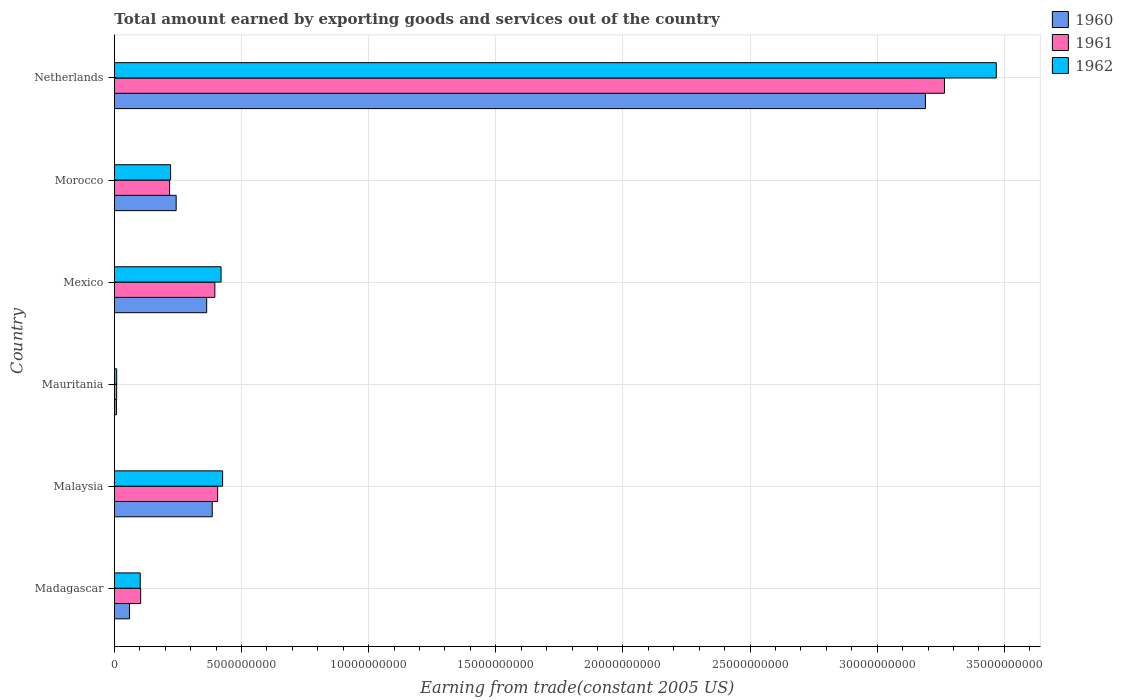How many bars are there on the 1st tick from the top?
Offer a very short reply. 3. What is the label of the 5th group of bars from the top?
Make the answer very short. Malaysia. In how many cases, is the number of bars for a given country not equal to the number of legend labels?
Offer a very short reply. 0. What is the total amount earned by exporting goods and services in 1961 in Malaysia?
Offer a terse response. 4.06e+09. Across all countries, what is the maximum total amount earned by exporting goods and services in 1962?
Keep it short and to the point. 3.47e+1. Across all countries, what is the minimum total amount earned by exporting goods and services in 1961?
Give a very brief answer. 8.64e+07. In which country was the total amount earned by exporting goods and services in 1961 maximum?
Your answer should be very brief. Netherlands. In which country was the total amount earned by exporting goods and services in 1962 minimum?
Offer a terse response. Mauritania. What is the total total amount earned by exporting goods and services in 1962 in the graph?
Offer a terse response. 4.64e+1. What is the difference between the total amount earned by exporting goods and services in 1961 in Malaysia and that in Mexico?
Give a very brief answer. 1.10e+08. What is the difference between the total amount earned by exporting goods and services in 1960 in Netherlands and the total amount earned by exporting goods and services in 1962 in Madagascar?
Provide a short and direct response. 3.09e+1. What is the average total amount earned by exporting goods and services in 1962 per country?
Make the answer very short. 7.74e+09. What is the difference between the total amount earned by exporting goods and services in 1960 and total amount earned by exporting goods and services in 1961 in Morocco?
Offer a very short reply. 2.59e+08. What is the ratio of the total amount earned by exporting goods and services in 1961 in Mauritania to that in Morocco?
Your answer should be compact. 0.04. Is the total amount earned by exporting goods and services in 1960 in Madagascar less than that in Mexico?
Offer a terse response. Yes. What is the difference between the highest and the second highest total amount earned by exporting goods and services in 1962?
Make the answer very short. 3.04e+1. What is the difference between the highest and the lowest total amount earned by exporting goods and services in 1962?
Your answer should be very brief. 3.46e+1. In how many countries, is the total amount earned by exporting goods and services in 1960 greater than the average total amount earned by exporting goods and services in 1960 taken over all countries?
Offer a very short reply. 1. What does the 1st bar from the top in Mexico represents?
Give a very brief answer. 1962. How many bars are there?
Provide a short and direct response. 18. What is the difference between two consecutive major ticks on the X-axis?
Offer a terse response. 5.00e+09. Where does the legend appear in the graph?
Offer a very short reply. Top right. How are the legend labels stacked?
Make the answer very short. Vertical. What is the title of the graph?
Your answer should be compact. Total amount earned by exporting goods and services out of the country. Does "1961" appear as one of the legend labels in the graph?
Give a very brief answer. Yes. What is the label or title of the X-axis?
Ensure brevity in your answer.  Earning from trade(constant 2005 US). What is the Earning from trade(constant 2005 US) in 1960 in Madagascar?
Provide a short and direct response. 5.92e+08. What is the Earning from trade(constant 2005 US) in 1961 in Madagascar?
Keep it short and to the point. 1.03e+09. What is the Earning from trade(constant 2005 US) in 1962 in Madagascar?
Provide a succinct answer. 1.02e+09. What is the Earning from trade(constant 2005 US) of 1960 in Malaysia?
Ensure brevity in your answer.  3.85e+09. What is the Earning from trade(constant 2005 US) of 1961 in Malaysia?
Offer a terse response. 4.06e+09. What is the Earning from trade(constant 2005 US) in 1962 in Malaysia?
Offer a terse response. 4.25e+09. What is the Earning from trade(constant 2005 US) of 1960 in Mauritania?
Provide a succinct answer. 7.97e+07. What is the Earning from trade(constant 2005 US) in 1961 in Mauritania?
Your answer should be compact. 8.64e+07. What is the Earning from trade(constant 2005 US) of 1962 in Mauritania?
Your answer should be compact. 8.95e+07. What is the Earning from trade(constant 2005 US) in 1960 in Mexico?
Make the answer very short. 3.63e+09. What is the Earning from trade(constant 2005 US) of 1961 in Mexico?
Give a very brief answer. 3.95e+09. What is the Earning from trade(constant 2005 US) in 1962 in Mexico?
Make the answer very short. 4.19e+09. What is the Earning from trade(constant 2005 US) in 1960 in Morocco?
Your answer should be compact. 2.43e+09. What is the Earning from trade(constant 2005 US) of 1961 in Morocco?
Ensure brevity in your answer.  2.17e+09. What is the Earning from trade(constant 2005 US) of 1962 in Morocco?
Offer a very short reply. 2.21e+09. What is the Earning from trade(constant 2005 US) in 1960 in Netherlands?
Offer a very short reply. 3.19e+1. What is the Earning from trade(constant 2005 US) in 1961 in Netherlands?
Keep it short and to the point. 3.26e+1. What is the Earning from trade(constant 2005 US) of 1962 in Netherlands?
Make the answer very short. 3.47e+1. Across all countries, what is the maximum Earning from trade(constant 2005 US) in 1960?
Ensure brevity in your answer.  3.19e+1. Across all countries, what is the maximum Earning from trade(constant 2005 US) in 1961?
Give a very brief answer. 3.26e+1. Across all countries, what is the maximum Earning from trade(constant 2005 US) in 1962?
Ensure brevity in your answer.  3.47e+1. Across all countries, what is the minimum Earning from trade(constant 2005 US) of 1960?
Your answer should be compact. 7.97e+07. Across all countries, what is the minimum Earning from trade(constant 2005 US) of 1961?
Your response must be concise. 8.64e+07. Across all countries, what is the minimum Earning from trade(constant 2005 US) of 1962?
Offer a very short reply. 8.95e+07. What is the total Earning from trade(constant 2005 US) in 1960 in the graph?
Your answer should be very brief. 4.25e+1. What is the total Earning from trade(constant 2005 US) in 1961 in the graph?
Your answer should be compact. 4.39e+1. What is the total Earning from trade(constant 2005 US) of 1962 in the graph?
Your answer should be very brief. 4.64e+1. What is the difference between the Earning from trade(constant 2005 US) of 1960 in Madagascar and that in Malaysia?
Offer a terse response. -3.26e+09. What is the difference between the Earning from trade(constant 2005 US) of 1961 in Madagascar and that in Malaysia?
Your response must be concise. -3.03e+09. What is the difference between the Earning from trade(constant 2005 US) in 1962 in Madagascar and that in Malaysia?
Provide a succinct answer. -3.24e+09. What is the difference between the Earning from trade(constant 2005 US) of 1960 in Madagascar and that in Mauritania?
Offer a terse response. 5.12e+08. What is the difference between the Earning from trade(constant 2005 US) of 1961 in Madagascar and that in Mauritania?
Provide a short and direct response. 9.45e+08. What is the difference between the Earning from trade(constant 2005 US) of 1962 in Madagascar and that in Mauritania?
Offer a terse response. 9.26e+08. What is the difference between the Earning from trade(constant 2005 US) of 1960 in Madagascar and that in Mexico?
Your answer should be very brief. -3.04e+09. What is the difference between the Earning from trade(constant 2005 US) in 1961 in Madagascar and that in Mexico?
Offer a very short reply. -2.92e+09. What is the difference between the Earning from trade(constant 2005 US) of 1962 in Madagascar and that in Mexico?
Provide a succinct answer. -3.18e+09. What is the difference between the Earning from trade(constant 2005 US) of 1960 in Madagascar and that in Morocco?
Offer a terse response. -1.84e+09. What is the difference between the Earning from trade(constant 2005 US) in 1961 in Madagascar and that in Morocco?
Keep it short and to the point. -1.14e+09. What is the difference between the Earning from trade(constant 2005 US) of 1962 in Madagascar and that in Morocco?
Provide a short and direct response. -1.19e+09. What is the difference between the Earning from trade(constant 2005 US) of 1960 in Madagascar and that in Netherlands?
Give a very brief answer. -3.13e+1. What is the difference between the Earning from trade(constant 2005 US) in 1961 in Madagascar and that in Netherlands?
Offer a terse response. -3.16e+1. What is the difference between the Earning from trade(constant 2005 US) in 1962 in Madagascar and that in Netherlands?
Your answer should be very brief. -3.37e+1. What is the difference between the Earning from trade(constant 2005 US) in 1960 in Malaysia and that in Mauritania?
Give a very brief answer. 3.77e+09. What is the difference between the Earning from trade(constant 2005 US) of 1961 in Malaysia and that in Mauritania?
Offer a terse response. 3.97e+09. What is the difference between the Earning from trade(constant 2005 US) of 1962 in Malaysia and that in Mauritania?
Your answer should be very brief. 4.17e+09. What is the difference between the Earning from trade(constant 2005 US) in 1960 in Malaysia and that in Mexico?
Make the answer very short. 2.18e+08. What is the difference between the Earning from trade(constant 2005 US) in 1961 in Malaysia and that in Mexico?
Your response must be concise. 1.10e+08. What is the difference between the Earning from trade(constant 2005 US) in 1962 in Malaysia and that in Mexico?
Ensure brevity in your answer.  6.04e+07. What is the difference between the Earning from trade(constant 2005 US) of 1960 in Malaysia and that in Morocco?
Your response must be concise. 1.42e+09. What is the difference between the Earning from trade(constant 2005 US) in 1961 in Malaysia and that in Morocco?
Give a very brief answer. 1.89e+09. What is the difference between the Earning from trade(constant 2005 US) in 1962 in Malaysia and that in Morocco?
Your answer should be compact. 2.05e+09. What is the difference between the Earning from trade(constant 2005 US) in 1960 in Malaysia and that in Netherlands?
Your response must be concise. -2.81e+1. What is the difference between the Earning from trade(constant 2005 US) in 1961 in Malaysia and that in Netherlands?
Your response must be concise. -2.86e+1. What is the difference between the Earning from trade(constant 2005 US) in 1962 in Malaysia and that in Netherlands?
Your response must be concise. -3.04e+1. What is the difference between the Earning from trade(constant 2005 US) in 1960 in Mauritania and that in Mexico?
Provide a short and direct response. -3.55e+09. What is the difference between the Earning from trade(constant 2005 US) of 1961 in Mauritania and that in Mexico?
Give a very brief answer. -3.86e+09. What is the difference between the Earning from trade(constant 2005 US) in 1962 in Mauritania and that in Mexico?
Your answer should be compact. -4.10e+09. What is the difference between the Earning from trade(constant 2005 US) of 1960 in Mauritania and that in Morocco?
Offer a very short reply. -2.35e+09. What is the difference between the Earning from trade(constant 2005 US) of 1961 in Mauritania and that in Morocco?
Make the answer very short. -2.08e+09. What is the difference between the Earning from trade(constant 2005 US) of 1962 in Mauritania and that in Morocco?
Your answer should be compact. -2.12e+09. What is the difference between the Earning from trade(constant 2005 US) of 1960 in Mauritania and that in Netherlands?
Your response must be concise. -3.18e+1. What is the difference between the Earning from trade(constant 2005 US) of 1961 in Mauritania and that in Netherlands?
Make the answer very short. -3.26e+1. What is the difference between the Earning from trade(constant 2005 US) in 1962 in Mauritania and that in Netherlands?
Offer a terse response. -3.46e+1. What is the difference between the Earning from trade(constant 2005 US) of 1960 in Mexico and that in Morocco?
Your answer should be very brief. 1.20e+09. What is the difference between the Earning from trade(constant 2005 US) in 1961 in Mexico and that in Morocco?
Offer a terse response. 1.78e+09. What is the difference between the Earning from trade(constant 2005 US) in 1962 in Mexico and that in Morocco?
Your response must be concise. 1.99e+09. What is the difference between the Earning from trade(constant 2005 US) in 1960 in Mexico and that in Netherlands?
Keep it short and to the point. -2.83e+1. What is the difference between the Earning from trade(constant 2005 US) in 1961 in Mexico and that in Netherlands?
Keep it short and to the point. -2.87e+1. What is the difference between the Earning from trade(constant 2005 US) in 1962 in Mexico and that in Netherlands?
Offer a terse response. -3.05e+1. What is the difference between the Earning from trade(constant 2005 US) of 1960 in Morocco and that in Netherlands?
Provide a succinct answer. -2.95e+1. What is the difference between the Earning from trade(constant 2005 US) in 1961 in Morocco and that in Netherlands?
Your answer should be compact. -3.05e+1. What is the difference between the Earning from trade(constant 2005 US) in 1962 in Morocco and that in Netherlands?
Your answer should be compact. -3.25e+1. What is the difference between the Earning from trade(constant 2005 US) in 1960 in Madagascar and the Earning from trade(constant 2005 US) in 1961 in Malaysia?
Offer a terse response. -3.47e+09. What is the difference between the Earning from trade(constant 2005 US) in 1960 in Madagascar and the Earning from trade(constant 2005 US) in 1962 in Malaysia?
Keep it short and to the point. -3.66e+09. What is the difference between the Earning from trade(constant 2005 US) in 1961 in Madagascar and the Earning from trade(constant 2005 US) in 1962 in Malaysia?
Ensure brevity in your answer.  -3.22e+09. What is the difference between the Earning from trade(constant 2005 US) in 1960 in Madagascar and the Earning from trade(constant 2005 US) in 1961 in Mauritania?
Offer a terse response. 5.05e+08. What is the difference between the Earning from trade(constant 2005 US) of 1960 in Madagascar and the Earning from trade(constant 2005 US) of 1962 in Mauritania?
Give a very brief answer. 5.02e+08. What is the difference between the Earning from trade(constant 2005 US) in 1961 in Madagascar and the Earning from trade(constant 2005 US) in 1962 in Mauritania?
Your answer should be very brief. 9.42e+08. What is the difference between the Earning from trade(constant 2005 US) of 1960 in Madagascar and the Earning from trade(constant 2005 US) of 1961 in Mexico?
Provide a succinct answer. -3.36e+09. What is the difference between the Earning from trade(constant 2005 US) of 1960 in Madagascar and the Earning from trade(constant 2005 US) of 1962 in Mexico?
Provide a succinct answer. -3.60e+09. What is the difference between the Earning from trade(constant 2005 US) in 1961 in Madagascar and the Earning from trade(constant 2005 US) in 1962 in Mexico?
Your response must be concise. -3.16e+09. What is the difference between the Earning from trade(constant 2005 US) of 1960 in Madagascar and the Earning from trade(constant 2005 US) of 1961 in Morocco?
Ensure brevity in your answer.  -1.58e+09. What is the difference between the Earning from trade(constant 2005 US) in 1960 in Madagascar and the Earning from trade(constant 2005 US) in 1962 in Morocco?
Make the answer very short. -1.62e+09. What is the difference between the Earning from trade(constant 2005 US) in 1961 in Madagascar and the Earning from trade(constant 2005 US) in 1962 in Morocco?
Provide a short and direct response. -1.18e+09. What is the difference between the Earning from trade(constant 2005 US) of 1960 in Madagascar and the Earning from trade(constant 2005 US) of 1961 in Netherlands?
Your answer should be very brief. -3.21e+1. What is the difference between the Earning from trade(constant 2005 US) in 1960 in Madagascar and the Earning from trade(constant 2005 US) in 1962 in Netherlands?
Provide a short and direct response. -3.41e+1. What is the difference between the Earning from trade(constant 2005 US) in 1961 in Madagascar and the Earning from trade(constant 2005 US) in 1962 in Netherlands?
Provide a short and direct response. -3.37e+1. What is the difference between the Earning from trade(constant 2005 US) in 1960 in Malaysia and the Earning from trade(constant 2005 US) in 1961 in Mauritania?
Offer a terse response. 3.76e+09. What is the difference between the Earning from trade(constant 2005 US) of 1960 in Malaysia and the Earning from trade(constant 2005 US) of 1962 in Mauritania?
Your answer should be very brief. 3.76e+09. What is the difference between the Earning from trade(constant 2005 US) in 1961 in Malaysia and the Earning from trade(constant 2005 US) in 1962 in Mauritania?
Keep it short and to the point. 3.97e+09. What is the difference between the Earning from trade(constant 2005 US) of 1960 in Malaysia and the Earning from trade(constant 2005 US) of 1961 in Mexico?
Offer a very short reply. -1.02e+08. What is the difference between the Earning from trade(constant 2005 US) in 1960 in Malaysia and the Earning from trade(constant 2005 US) in 1962 in Mexico?
Your answer should be compact. -3.48e+08. What is the difference between the Earning from trade(constant 2005 US) in 1961 in Malaysia and the Earning from trade(constant 2005 US) in 1962 in Mexico?
Provide a succinct answer. -1.35e+08. What is the difference between the Earning from trade(constant 2005 US) of 1960 in Malaysia and the Earning from trade(constant 2005 US) of 1961 in Morocco?
Your answer should be very brief. 1.68e+09. What is the difference between the Earning from trade(constant 2005 US) in 1960 in Malaysia and the Earning from trade(constant 2005 US) in 1962 in Morocco?
Offer a terse response. 1.64e+09. What is the difference between the Earning from trade(constant 2005 US) in 1961 in Malaysia and the Earning from trade(constant 2005 US) in 1962 in Morocco?
Provide a succinct answer. 1.85e+09. What is the difference between the Earning from trade(constant 2005 US) in 1960 in Malaysia and the Earning from trade(constant 2005 US) in 1961 in Netherlands?
Provide a short and direct response. -2.88e+1. What is the difference between the Earning from trade(constant 2005 US) of 1960 in Malaysia and the Earning from trade(constant 2005 US) of 1962 in Netherlands?
Ensure brevity in your answer.  -3.08e+1. What is the difference between the Earning from trade(constant 2005 US) of 1961 in Malaysia and the Earning from trade(constant 2005 US) of 1962 in Netherlands?
Ensure brevity in your answer.  -3.06e+1. What is the difference between the Earning from trade(constant 2005 US) of 1960 in Mauritania and the Earning from trade(constant 2005 US) of 1961 in Mexico?
Your answer should be compact. -3.87e+09. What is the difference between the Earning from trade(constant 2005 US) in 1960 in Mauritania and the Earning from trade(constant 2005 US) in 1962 in Mexico?
Make the answer very short. -4.11e+09. What is the difference between the Earning from trade(constant 2005 US) in 1961 in Mauritania and the Earning from trade(constant 2005 US) in 1962 in Mexico?
Ensure brevity in your answer.  -4.11e+09. What is the difference between the Earning from trade(constant 2005 US) in 1960 in Mauritania and the Earning from trade(constant 2005 US) in 1961 in Morocco?
Your answer should be compact. -2.09e+09. What is the difference between the Earning from trade(constant 2005 US) of 1960 in Mauritania and the Earning from trade(constant 2005 US) of 1962 in Morocco?
Your answer should be compact. -2.13e+09. What is the difference between the Earning from trade(constant 2005 US) of 1961 in Mauritania and the Earning from trade(constant 2005 US) of 1962 in Morocco?
Provide a succinct answer. -2.12e+09. What is the difference between the Earning from trade(constant 2005 US) in 1960 in Mauritania and the Earning from trade(constant 2005 US) in 1961 in Netherlands?
Your response must be concise. -3.26e+1. What is the difference between the Earning from trade(constant 2005 US) in 1960 in Mauritania and the Earning from trade(constant 2005 US) in 1962 in Netherlands?
Keep it short and to the point. -3.46e+1. What is the difference between the Earning from trade(constant 2005 US) in 1961 in Mauritania and the Earning from trade(constant 2005 US) in 1962 in Netherlands?
Keep it short and to the point. -3.46e+1. What is the difference between the Earning from trade(constant 2005 US) of 1960 in Mexico and the Earning from trade(constant 2005 US) of 1961 in Morocco?
Your answer should be very brief. 1.46e+09. What is the difference between the Earning from trade(constant 2005 US) in 1960 in Mexico and the Earning from trade(constant 2005 US) in 1962 in Morocco?
Your answer should be very brief. 1.42e+09. What is the difference between the Earning from trade(constant 2005 US) in 1961 in Mexico and the Earning from trade(constant 2005 US) in 1962 in Morocco?
Make the answer very short. 1.74e+09. What is the difference between the Earning from trade(constant 2005 US) in 1960 in Mexico and the Earning from trade(constant 2005 US) in 1961 in Netherlands?
Your response must be concise. -2.90e+1. What is the difference between the Earning from trade(constant 2005 US) in 1960 in Mexico and the Earning from trade(constant 2005 US) in 1962 in Netherlands?
Ensure brevity in your answer.  -3.11e+1. What is the difference between the Earning from trade(constant 2005 US) of 1961 in Mexico and the Earning from trade(constant 2005 US) of 1962 in Netherlands?
Provide a succinct answer. -3.07e+1. What is the difference between the Earning from trade(constant 2005 US) in 1960 in Morocco and the Earning from trade(constant 2005 US) in 1961 in Netherlands?
Offer a terse response. -3.02e+1. What is the difference between the Earning from trade(constant 2005 US) in 1960 in Morocco and the Earning from trade(constant 2005 US) in 1962 in Netherlands?
Keep it short and to the point. -3.23e+1. What is the difference between the Earning from trade(constant 2005 US) of 1961 in Morocco and the Earning from trade(constant 2005 US) of 1962 in Netherlands?
Your answer should be compact. -3.25e+1. What is the average Earning from trade(constant 2005 US) in 1960 per country?
Your answer should be very brief. 7.08e+09. What is the average Earning from trade(constant 2005 US) of 1961 per country?
Make the answer very short. 7.32e+09. What is the average Earning from trade(constant 2005 US) of 1962 per country?
Provide a succinct answer. 7.74e+09. What is the difference between the Earning from trade(constant 2005 US) of 1960 and Earning from trade(constant 2005 US) of 1961 in Madagascar?
Keep it short and to the point. -4.40e+08. What is the difference between the Earning from trade(constant 2005 US) of 1960 and Earning from trade(constant 2005 US) of 1962 in Madagascar?
Make the answer very short. -4.24e+08. What is the difference between the Earning from trade(constant 2005 US) in 1961 and Earning from trade(constant 2005 US) in 1962 in Madagascar?
Ensure brevity in your answer.  1.61e+07. What is the difference between the Earning from trade(constant 2005 US) in 1960 and Earning from trade(constant 2005 US) in 1961 in Malaysia?
Your response must be concise. -2.13e+08. What is the difference between the Earning from trade(constant 2005 US) of 1960 and Earning from trade(constant 2005 US) of 1962 in Malaysia?
Ensure brevity in your answer.  -4.08e+08. What is the difference between the Earning from trade(constant 2005 US) in 1961 and Earning from trade(constant 2005 US) in 1962 in Malaysia?
Ensure brevity in your answer.  -1.95e+08. What is the difference between the Earning from trade(constant 2005 US) of 1960 and Earning from trade(constant 2005 US) of 1961 in Mauritania?
Offer a terse response. -6.74e+06. What is the difference between the Earning from trade(constant 2005 US) of 1960 and Earning from trade(constant 2005 US) of 1962 in Mauritania?
Provide a short and direct response. -9.81e+06. What is the difference between the Earning from trade(constant 2005 US) in 1961 and Earning from trade(constant 2005 US) in 1962 in Mauritania?
Provide a short and direct response. -3.07e+06. What is the difference between the Earning from trade(constant 2005 US) of 1960 and Earning from trade(constant 2005 US) of 1961 in Mexico?
Ensure brevity in your answer.  -3.21e+08. What is the difference between the Earning from trade(constant 2005 US) of 1960 and Earning from trade(constant 2005 US) of 1962 in Mexico?
Keep it short and to the point. -5.66e+08. What is the difference between the Earning from trade(constant 2005 US) in 1961 and Earning from trade(constant 2005 US) in 1962 in Mexico?
Your answer should be compact. -2.45e+08. What is the difference between the Earning from trade(constant 2005 US) in 1960 and Earning from trade(constant 2005 US) in 1961 in Morocco?
Make the answer very short. 2.59e+08. What is the difference between the Earning from trade(constant 2005 US) in 1960 and Earning from trade(constant 2005 US) in 1962 in Morocco?
Ensure brevity in your answer.  2.19e+08. What is the difference between the Earning from trade(constant 2005 US) of 1961 and Earning from trade(constant 2005 US) of 1962 in Morocco?
Ensure brevity in your answer.  -3.93e+07. What is the difference between the Earning from trade(constant 2005 US) of 1960 and Earning from trade(constant 2005 US) of 1961 in Netherlands?
Ensure brevity in your answer.  -7.48e+08. What is the difference between the Earning from trade(constant 2005 US) of 1960 and Earning from trade(constant 2005 US) of 1962 in Netherlands?
Offer a terse response. -2.79e+09. What is the difference between the Earning from trade(constant 2005 US) in 1961 and Earning from trade(constant 2005 US) in 1962 in Netherlands?
Offer a terse response. -2.04e+09. What is the ratio of the Earning from trade(constant 2005 US) of 1960 in Madagascar to that in Malaysia?
Make the answer very short. 0.15. What is the ratio of the Earning from trade(constant 2005 US) of 1961 in Madagascar to that in Malaysia?
Your answer should be compact. 0.25. What is the ratio of the Earning from trade(constant 2005 US) of 1962 in Madagascar to that in Malaysia?
Give a very brief answer. 0.24. What is the ratio of the Earning from trade(constant 2005 US) in 1960 in Madagascar to that in Mauritania?
Provide a succinct answer. 7.42. What is the ratio of the Earning from trade(constant 2005 US) of 1961 in Madagascar to that in Mauritania?
Your response must be concise. 11.93. What is the ratio of the Earning from trade(constant 2005 US) in 1962 in Madagascar to that in Mauritania?
Offer a very short reply. 11.34. What is the ratio of the Earning from trade(constant 2005 US) of 1960 in Madagascar to that in Mexico?
Give a very brief answer. 0.16. What is the ratio of the Earning from trade(constant 2005 US) in 1961 in Madagascar to that in Mexico?
Provide a short and direct response. 0.26. What is the ratio of the Earning from trade(constant 2005 US) of 1962 in Madagascar to that in Mexico?
Make the answer very short. 0.24. What is the ratio of the Earning from trade(constant 2005 US) in 1960 in Madagascar to that in Morocco?
Your answer should be very brief. 0.24. What is the ratio of the Earning from trade(constant 2005 US) of 1961 in Madagascar to that in Morocco?
Make the answer very short. 0.48. What is the ratio of the Earning from trade(constant 2005 US) of 1962 in Madagascar to that in Morocco?
Keep it short and to the point. 0.46. What is the ratio of the Earning from trade(constant 2005 US) in 1960 in Madagascar to that in Netherlands?
Offer a very short reply. 0.02. What is the ratio of the Earning from trade(constant 2005 US) in 1961 in Madagascar to that in Netherlands?
Provide a short and direct response. 0.03. What is the ratio of the Earning from trade(constant 2005 US) of 1962 in Madagascar to that in Netherlands?
Provide a succinct answer. 0.03. What is the ratio of the Earning from trade(constant 2005 US) of 1960 in Malaysia to that in Mauritania?
Provide a short and direct response. 48.26. What is the ratio of the Earning from trade(constant 2005 US) of 1961 in Malaysia to that in Mauritania?
Offer a very short reply. 46.96. What is the ratio of the Earning from trade(constant 2005 US) in 1962 in Malaysia to that in Mauritania?
Ensure brevity in your answer.  47.53. What is the ratio of the Earning from trade(constant 2005 US) of 1960 in Malaysia to that in Mexico?
Give a very brief answer. 1.06. What is the ratio of the Earning from trade(constant 2005 US) in 1961 in Malaysia to that in Mexico?
Your answer should be compact. 1.03. What is the ratio of the Earning from trade(constant 2005 US) in 1962 in Malaysia to that in Mexico?
Ensure brevity in your answer.  1.01. What is the ratio of the Earning from trade(constant 2005 US) in 1960 in Malaysia to that in Morocco?
Offer a very short reply. 1.58. What is the ratio of the Earning from trade(constant 2005 US) of 1961 in Malaysia to that in Morocco?
Provide a succinct answer. 1.87. What is the ratio of the Earning from trade(constant 2005 US) in 1962 in Malaysia to that in Morocco?
Provide a short and direct response. 1.93. What is the ratio of the Earning from trade(constant 2005 US) of 1960 in Malaysia to that in Netherlands?
Offer a very short reply. 0.12. What is the ratio of the Earning from trade(constant 2005 US) of 1961 in Malaysia to that in Netherlands?
Give a very brief answer. 0.12. What is the ratio of the Earning from trade(constant 2005 US) of 1962 in Malaysia to that in Netherlands?
Make the answer very short. 0.12. What is the ratio of the Earning from trade(constant 2005 US) in 1960 in Mauritania to that in Mexico?
Your answer should be compact. 0.02. What is the ratio of the Earning from trade(constant 2005 US) in 1961 in Mauritania to that in Mexico?
Your answer should be compact. 0.02. What is the ratio of the Earning from trade(constant 2005 US) in 1962 in Mauritania to that in Mexico?
Make the answer very short. 0.02. What is the ratio of the Earning from trade(constant 2005 US) of 1960 in Mauritania to that in Morocco?
Ensure brevity in your answer.  0.03. What is the ratio of the Earning from trade(constant 2005 US) in 1961 in Mauritania to that in Morocco?
Your answer should be very brief. 0.04. What is the ratio of the Earning from trade(constant 2005 US) of 1962 in Mauritania to that in Morocco?
Your answer should be compact. 0.04. What is the ratio of the Earning from trade(constant 2005 US) of 1960 in Mauritania to that in Netherlands?
Your answer should be compact. 0. What is the ratio of the Earning from trade(constant 2005 US) of 1961 in Mauritania to that in Netherlands?
Ensure brevity in your answer.  0. What is the ratio of the Earning from trade(constant 2005 US) in 1962 in Mauritania to that in Netherlands?
Your response must be concise. 0. What is the ratio of the Earning from trade(constant 2005 US) of 1960 in Mexico to that in Morocco?
Provide a short and direct response. 1.49. What is the ratio of the Earning from trade(constant 2005 US) of 1961 in Mexico to that in Morocco?
Offer a terse response. 1.82. What is the ratio of the Earning from trade(constant 2005 US) of 1962 in Mexico to that in Morocco?
Provide a short and direct response. 1.9. What is the ratio of the Earning from trade(constant 2005 US) in 1960 in Mexico to that in Netherlands?
Ensure brevity in your answer.  0.11. What is the ratio of the Earning from trade(constant 2005 US) in 1961 in Mexico to that in Netherlands?
Give a very brief answer. 0.12. What is the ratio of the Earning from trade(constant 2005 US) of 1962 in Mexico to that in Netherlands?
Your answer should be very brief. 0.12. What is the ratio of the Earning from trade(constant 2005 US) in 1960 in Morocco to that in Netherlands?
Offer a very short reply. 0.08. What is the ratio of the Earning from trade(constant 2005 US) in 1961 in Morocco to that in Netherlands?
Ensure brevity in your answer.  0.07. What is the ratio of the Earning from trade(constant 2005 US) of 1962 in Morocco to that in Netherlands?
Keep it short and to the point. 0.06. What is the difference between the highest and the second highest Earning from trade(constant 2005 US) in 1960?
Your answer should be compact. 2.81e+1. What is the difference between the highest and the second highest Earning from trade(constant 2005 US) of 1961?
Give a very brief answer. 2.86e+1. What is the difference between the highest and the second highest Earning from trade(constant 2005 US) of 1962?
Your answer should be very brief. 3.04e+1. What is the difference between the highest and the lowest Earning from trade(constant 2005 US) of 1960?
Your response must be concise. 3.18e+1. What is the difference between the highest and the lowest Earning from trade(constant 2005 US) in 1961?
Provide a succinct answer. 3.26e+1. What is the difference between the highest and the lowest Earning from trade(constant 2005 US) in 1962?
Make the answer very short. 3.46e+1. 